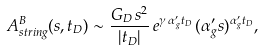Convert formula to latex. <formula><loc_0><loc_0><loc_500><loc_500>A ^ { B } _ { s t r i n g } ( s , t _ { D } ) \sim \frac { G _ { D } \, s ^ { 2 } } { | t _ { D } | } \, e ^ { \gamma \, \alpha _ { g } ^ { \prime } t _ { D } } \, ( \alpha _ { g } ^ { \prime } s ) ^ { \alpha _ { g } ^ { \prime } t _ { D } } ,</formula> 